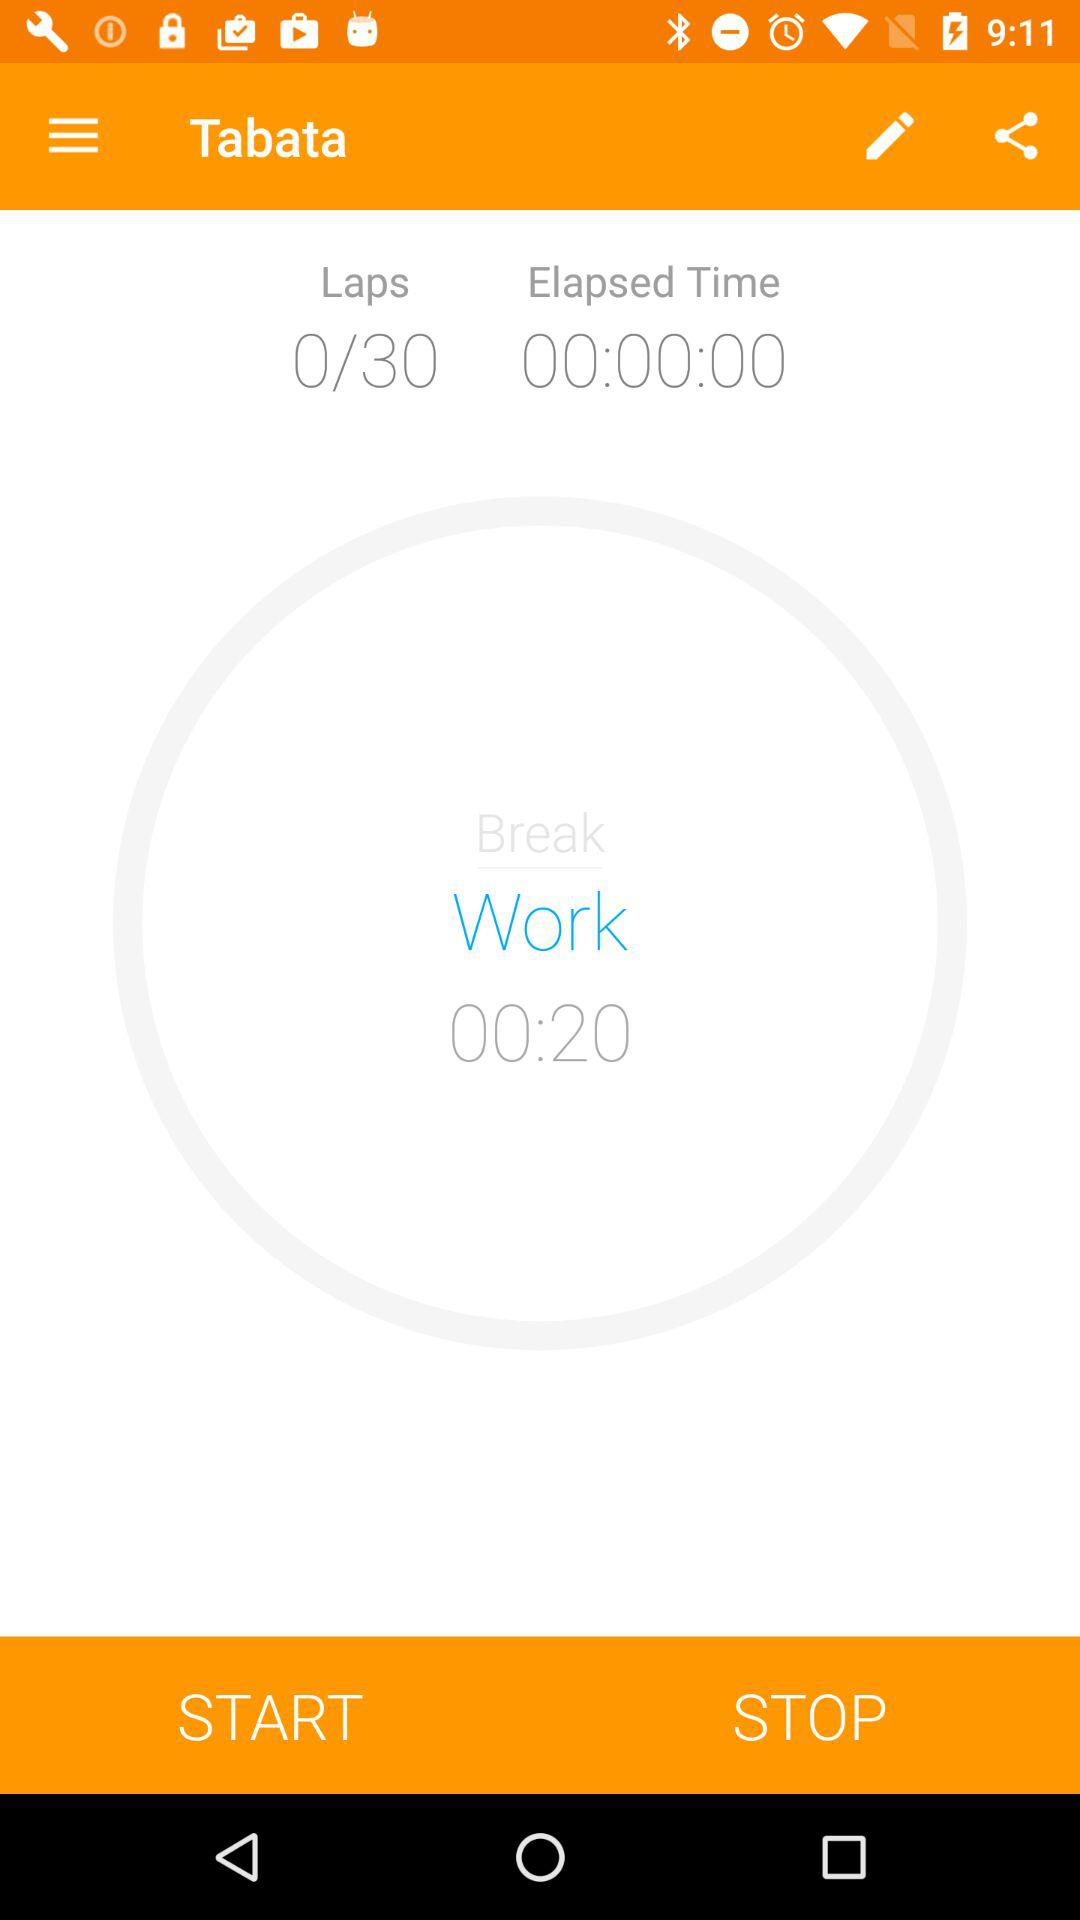How many total laps are there? There are 30 laps in total. 